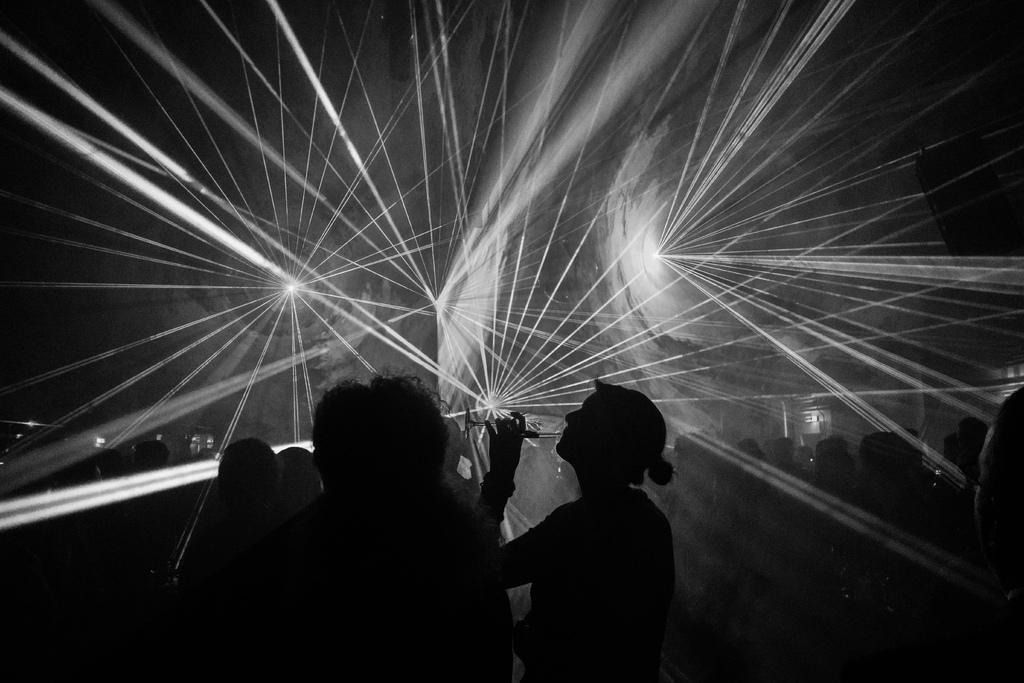Can you describe this image briefly? This is a black and white image. There are some persons in the middle. There are lights in the middle. 